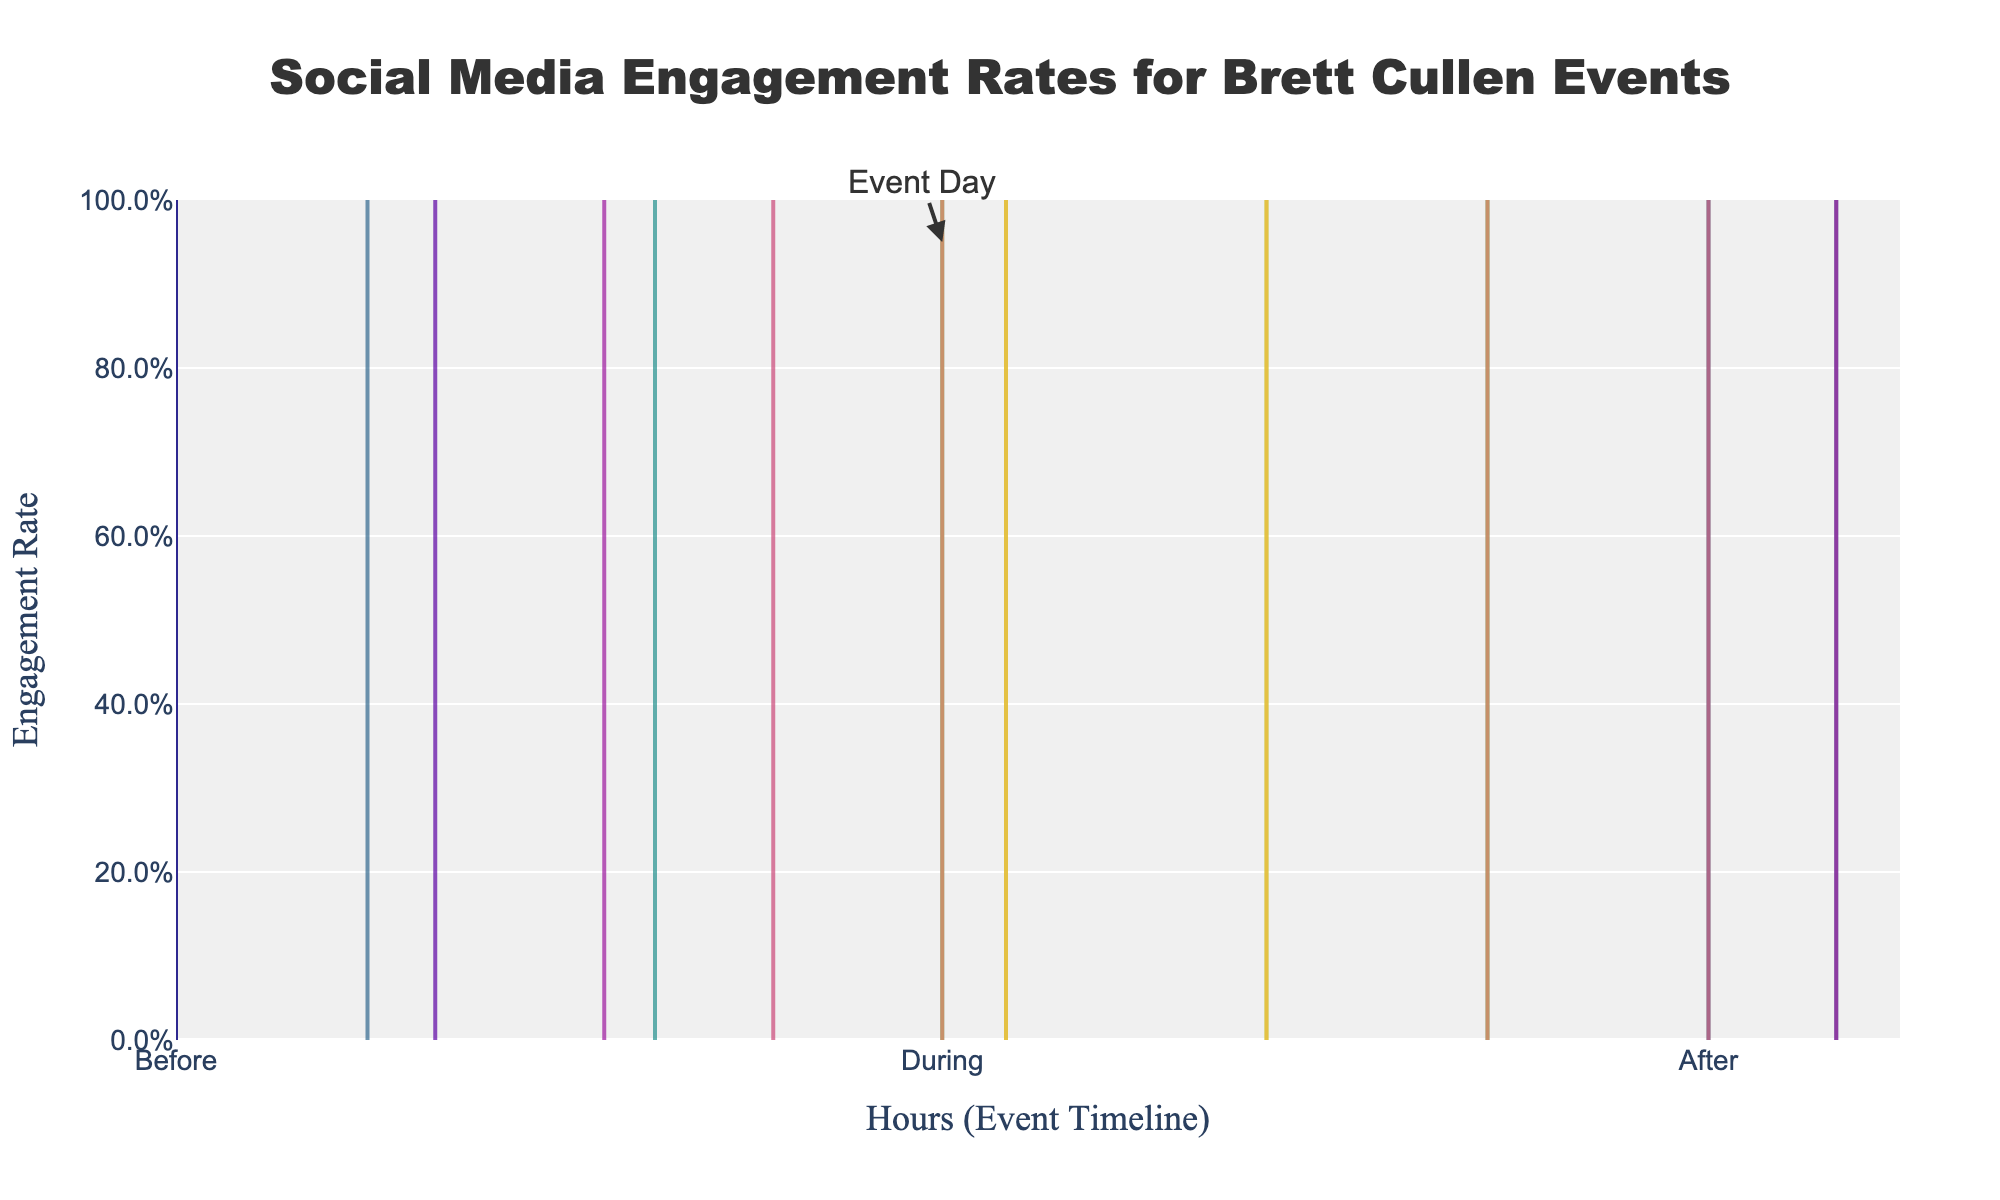What is the highest engagement rate recorded during the event on Twitter? The plot shows Twitter's engagement rate contour reaching its highest point during the event around the time labeled "During". The peak engagement rate for Twitter on the timeline "During" appears to be 0.040.
Answer: 0.040 How is the Instagram engagement rate during the event compared to before the event? The Instagram engagement rate during the event seems significantly higher than before the event. Around the "During" timeline, Instagram engagement peaks at 0.050, while before the event, the engagement rate does not exceed 0.023.
Answer: Higher during the event Which platform showed a more significant spike in engagement during the event? Comparing the engagement rates during the event, Instagram shows a more significant spike, reaching up to 0.050 compared to Twitter's highest of 0.040.
Answer: Instagram What can you infer about social media engagement rates after the event? Both Twitter and Instagram engagement rates decrease after the event. The contour lines for both platforms descend, with Instagram around 0.035 and Twitter around 0.025 at the beginning of the "After" period.
Answer: Both decrease How does the Twitter engagement rate change over time before, during, and after the event? The Twitter engagement rate rises steadily before the event, peaks during the event at 0.040, and then decreases again after the event. This trend is indicated by the contour lines curving upwards during the event and back downwards post-event.
Answer: Rises before, peaks during, decreases after 